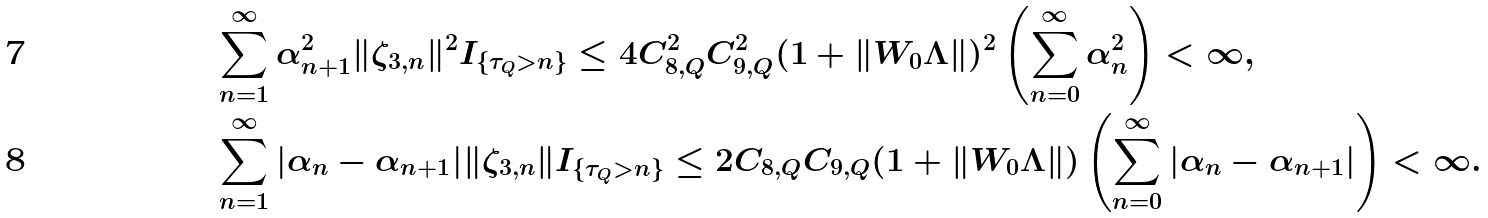Convert formula to latex. <formula><loc_0><loc_0><loc_500><loc_500>& \sum _ { n = 1 } ^ { \infty } \alpha _ { n + 1 } ^ { 2 } \| \zeta _ { 3 , n } \| ^ { 2 } I _ { \{ \tau _ { Q } > n \} } \leq 4 C _ { 8 , Q } ^ { 2 } C _ { 9 , Q } ^ { 2 } ( 1 + \| W _ { 0 } \Lambda \| ) ^ { 2 } \left ( \sum _ { n = 0 } ^ { \infty } \alpha _ { n } ^ { 2 } \right ) < \infty , \\ & \sum _ { n = 1 } ^ { \infty } | \alpha _ { n } - \alpha _ { n + 1 } | \| \zeta _ { 3 , n } \| I _ { \{ \tau _ { Q } > n \} } \leq 2 C _ { 8 , Q } C _ { 9 , Q } ( 1 + \| W _ { 0 } \Lambda \| ) \left ( \sum _ { n = 0 } ^ { \infty } | \alpha _ { n } - \alpha _ { n + 1 } | \right ) < \infty .</formula> 